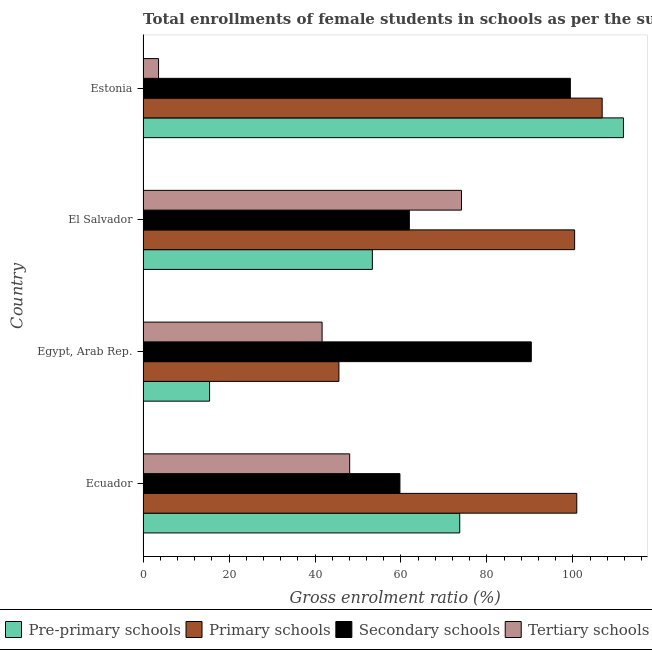How many groups of bars are there?
Give a very brief answer. 4. Are the number of bars per tick equal to the number of legend labels?
Give a very brief answer. Yes. Are the number of bars on each tick of the Y-axis equal?
Offer a terse response. Yes. What is the label of the 4th group of bars from the top?
Provide a succinct answer. Ecuador. In how many cases, is the number of bars for a given country not equal to the number of legend labels?
Keep it short and to the point. 0. What is the gross enrolment ratio(female) in tertiary schools in Ecuador?
Your answer should be very brief. 48.06. Across all countries, what is the maximum gross enrolment ratio(female) in primary schools?
Make the answer very short. 106.8. Across all countries, what is the minimum gross enrolment ratio(female) in tertiary schools?
Your response must be concise. 3.6. In which country was the gross enrolment ratio(female) in primary schools maximum?
Your response must be concise. Estonia. In which country was the gross enrolment ratio(female) in secondary schools minimum?
Provide a short and direct response. Ecuador. What is the total gross enrolment ratio(female) in secondary schools in the graph?
Give a very brief answer. 311.41. What is the difference between the gross enrolment ratio(female) in pre-primary schools in Ecuador and that in Estonia?
Your response must be concise. -38.09. What is the difference between the gross enrolment ratio(female) in primary schools in Ecuador and the gross enrolment ratio(female) in tertiary schools in Egypt, Arab Rep.?
Keep it short and to the point. 59.25. What is the average gross enrolment ratio(female) in secondary schools per country?
Offer a very short reply. 77.85. What is the difference between the gross enrolment ratio(female) in pre-primary schools and gross enrolment ratio(female) in primary schools in El Salvador?
Your answer should be very brief. -47.05. What is the ratio of the gross enrolment ratio(female) in tertiary schools in Ecuador to that in Estonia?
Keep it short and to the point. 13.34. Is the gross enrolment ratio(female) in primary schools in Egypt, Arab Rep. less than that in El Salvador?
Your answer should be compact. Yes. What is the difference between the highest and the second highest gross enrolment ratio(female) in pre-primary schools?
Give a very brief answer. 38.09. What is the difference between the highest and the lowest gross enrolment ratio(female) in pre-primary schools?
Provide a short and direct response. 96.28. Is the sum of the gross enrolment ratio(female) in tertiary schools in El Salvador and Estonia greater than the maximum gross enrolment ratio(female) in secondary schools across all countries?
Your answer should be very brief. No. Is it the case that in every country, the sum of the gross enrolment ratio(female) in tertiary schools and gross enrolment ratio(female) in pre-primary schools is greater than the sum of gross enrolment ratio(female) in secondary schools and gross enrolment ratio(female) in primary schools?
Your response must be concise. No. What does the 3rd bar from the top in El Salvador represents?
Keep it short and to the point. Primary schools. What does the 1st bar from the bottom in El Salvador represents?
Your answer should be very brief. Pre-primary schools. How many bars are there?
Offer a very short reply. 16. How many countries are there in the graph?
Offer a very short reply. 4. What is the difference between two consecutive major ticks on the X-axis?
Your answer should be very brief. 20. Are the values on the major ticks of X-axis written in scientific E-notation?
Your answer should be compact. No. Does the graph contain any zero values?
Provide a succinct answer. No. Does the graph contain grids?
Ensure brevity in your answer.  No. Where does the legend appear in the graph?
Provide a short and direct response. Bottom center. How are the legend labels stacked?
Provide a short and direct response. Horizontal. What is the title of the graph?
Your answer should be compact. Total enrollments of female students in schools as per the survey of 2004 conducted in different countries. Does "International Monetary Fund" appear as one of the legend labels in the graph?
Your answer should be very brief. No. What is the Gross enrolment ratio (%) in Pre-primary schools in Ecuador?
Offer a terse response. 73.67. What is the Gross enrolment ratio (%) of Primary schools in Ecuador?
Make the answer very short. 100.9. What is the Gross enrolment ratio (%) in Secondary schools in Ecuador?
Make the answer very short. 59.76. What is the Gross enrolment ratio (%) of Tertiary schools in Ecuador?
Keep it short and to the point. 48.06. What is the Gross enrolment ratio (%) in Pre-primary schools in Egypt, Arab Rep.?
Give a very brief answer. 15.47. What is the Gross enrolment ratio (%) of Primary schools in Egypt, Arab Rep.?
Offer a very short reply. 45.56. What is the Gross enrolment ratio (%) of Secondary schools in Egypt, Arab Rep.?
Give a very brief answer. 90.31. What is the Gross enrolment ratio (%) in Tertiary schools in Egypt, Arab Rep.?
Offer a very short reply. 41.65. What is the Gross enrolment ratio (%) of Pre-primary schools in El Salvador?
Offer a very short reply. 53.34. What is the Gross enrolment ratio (%) of Primary schools in El Salvador?
Offer a terse response. 100.39. What is the Gross enrolment ratio (%) in Secondary schools in El Salvador?
Your response must be concise. 61.94. What is the Gross enrolment ratio (%) in Tertiary schools in El Salvador?
Give a very brief answer. 74.07. What is the Gross enrolment ratio (%) in Pre-primary schools in Estonia?
Your response must be concise. 111.76. What is the Gross enrolment ratio (%) of Primary schools in Estonia?
Provide a succinct answer. 106.8. What is the Gross enrolment ratio (%) of Secondary schools in Estonia?
Offer a very short reply. 99.4. What is the Gross enrolment ratio (%) in Tertiary schools in Estonia?
Make the answer very short. 3.6. Across all countries, what is the maximum Gross enrolment ratio (%) of Pre-primary schools?
Offer a terse response. 111.76. Across all countries, what is the maximum Gross enrolment ratio (%) of Primary schools?
Provide a succinct answer. 106.8. Across all countries, what is the maximum Gross enrolment ratio (%) of Secondary schools?
Your answer should be compact. 99.4. Across all countries, what is the maximum Gross enrolment ratio (%) of Tertiary schools?
Ensure brevity in your answer.  74.07. Across all countries, what is the minimum Gross enrolment ratio (%) in Pre-primary schools?
Ensure brevity in your answer.  15.47. Across all countries, what is the minimum Gross enrolment ratio (%) of Primary schools?
Your response must be concise. 45.56. Across all countries, what is the minimum Gross enrolment ratio (%) of Secondary schools?
Offer a very short reply. 59.76. Across all countries, what is the minimum Gross enrolment ratio (%) of Tertiary schools?
Ensure brevity in your answer.  3.6. What is the total Gross enrolment ratio (%) in Pre-primary schools in the graph?
Your answer should be compact. 254.24. What is the total Gross enrolment ratio (%) of Primary schools in the graph?
Keep it short and to the point. 353.65. What is the total Gross enrolment ratio (%) of Secondary schools in the graph?
Provide a short and direct response. 311.41. What is the total Gross enrolment ratio (%) in Tertiary schools in the graph?
Your response must be concise. 167.39. What is the difference between the Gross enrolment ratio (%) in Pre-primary schools in Ecuador and that in Egypt, Arab Rep.?
Make the answer very short. 58.19. What is the difference between the Gross enrolment ratio (%) of Primary schools in Ecuador and that in Egypt, Arab Rep.?
Keep it short and to the point. 55.34. What is the difference between the Gross enrolment ratio (%) of Secondary schools in Ecuador and that in Egypt, Arab Rep.?
Provide a short and direct response. -30.56. What is the difference between the Gross enrolment ratio (%) of Tertiary schools in Ecuador and that in Egypt, Arab Rep.?
Your response must be concise. 6.42. What is the difference between the Gross enrolment ratio (%) in Pre-primary schools in Ecuador and that in El Salvador?
Provide a short and direct response. 20.33. What is the difference between the Gross enrolment ratio (%) in Primary schools in Ecuador and that in El Salvador?
Your answer should be very brief. 0.5. What is the difference between the Gross enrolment ratio (%) in Secondary schools in Ecuador and that in El Salvador?
Your answer should be very brief. -2.19. What is the difference between the Gross enrolment ratio (%) in Tertiary schools in Ecuador and that in El Salvador?
Offer a very short reply. -26.01. What is the difference between the Gross enrolment ratio (%) of Pre-primary schools in Ecuador and that in Estonia?
Offer a terse response. -38.09. What is the difference between the Gross enrolment ratio (%) in Primary schools in Ecuador and that in Estonia?
Offer a very short reply. -5.91. What is the difference between the Gross enrolment ratio (%) of Secondary schools in Ecuador and that in Estonia?
Give a very brief answer. -39.64. What is the difference between the Gross enrolment ratio (%) of Tertiary schools in Ecuador and that in Estonia?
Your answer should be compact. 44.46. What is the difference between the Gross enrolment ratio (%) in Pre-primary schools in Egypt, Arab Rep. and that in El Salvador?
Offer a very short reply. -37.87. What is the difference between the Gross enrolment ratio (%) of Primary schools in Egypt, Arab Rep. and that in El Salvador?
Give a very brief answer. -54.83. What is the difference between the Gross enrolment ratio (%) of Secondary schools in Egypt, Arab Rep. and that in El Salvador?
Give a very brief answer. 28.37. What is the difference between the Gross enrolment ratio (%) in Tertiary schools in Egypt, Arab Rep. and that in El Salvador?
Offer a terse response. -32.43. What is the difference between the Gross enrolment ratio (%) of Pre-primary schools in Egypt, Arab Rep. and that in Estonia?
Give a very brief answer. -96.28. What is the difference between the Gross enrolment ratio (%) in Primary schools in Egypt, Arab Rep. and that in Estonia?
Provide a succinct answer. -61.24. What is the difference between the Gross enrolment ratio (%) of Secondary schools in Egypt, Arab Rep. and that in Estonia?
Offer a terse response. -9.08. What is the difference between the Gross enrolment ratio (%) in Tertiary schools in Egypt, Arab Rep. and that in Estonia?
Provide a short and direct response. 38.04. What is the difference between the Gross enrolment ratio (%) in Pre-primary schools in El Salvador and that in Estonia?
Provide a short and direct response. -58.41. What is the difference between the Gross enrolment ratio (%) of Primary schools in El Salvador and that in Estonia?
Your answer should be very brief. -6.41. What is the difference between the Gross enrolment ratio (%) in Secondary schools in El Salvador and that in Estonia?
Offer a very short reply. -37.45. What is the difference between the Gross enrolment ratio (%) in Tertiary schools in El Salvador and that in Estonia?
Give a very brief answer. 70.47. What is the difference between the Gross enrolment ratio (%) in Pre-primary schools in Ecuador and the Gross enrolment ratio (%) in Primary schools in Egypt, Arab Rep.?
Your answer should be compact. 28.11. What is the difference between the Gross enrolment ratio (%) of Pre-primary schools in Ecuador and the Gross enrolment ratio (%) of Secondary schools in Egypt, Arab Rep.?
Keep it short and to the point. -16.65. What is the difference between the Gross enrolment ratio (%) of Pre-primary schools in Ecuador and the Gross enrolment ratio (%) of Tertiary schools in Egypt, Arab Rep.?
Your answer should be compact. 32.02. What is the difference between the Gross enrolment ratio (%) in Primary schools in Ecuador and the Gross enrolment ratio (%) in Secondary schools in Egypt, Arab Rep.?
Your answer should be very brief. 10.58. What is the difference between the Gross enrolment ratio (%) in Primary schools in Ecuador and the Gross enrolment ratio (%) in Tertiary schools in Egypt, Arab Rep.?
Your response must be concise. 59.25. What is the difference between the Gross enrolment ratio (%) of Secondary schools in Ecuador and the Gross enrolment ratio (%) of Tertiary schools in Egypt, Arab Rep.?
Make the answer very short. 18.11. What is the difference between the Gross enrolment ratio (%) in Pre-primary schools in Ecuador and the Gross enrolment ratio (%) in Primary schools in El Salvador?
Your response must be concise. -26.73. What is the difference between the Gross enrolment ratio (%) of Pre-primary schools in Ecuador and the Gross enrolment ratio (%) of Secondary schools in El Salvador?
Provide a short and direct response. 11.72. What is the difference between the Gross enrolment ratio (%) in Pre-primary schools in Ecuador and the Gross enrolment ratio (%) in Tertiary schools in El Salvador?
Provide a succinct answer. -0.41. What is the difference between the Gross enrolment ratio (%) of Primary schools in Ecuador and the Gross enrolment ratio (%) of Secondary schools in El Salvador?
Give a very brief answer. 38.95. What is the difference between the Gross enrolment ratio (%) of Primary schools in Ecuador and the Gross enrolment ratio (%) of Tertiary schools in El Salvador?
Your answer should be compact. 26.82. What is the difference between the Gross enrolment ratio (%) of Secondary schools in Ecuador and the Gross enrolment ratio (%) of Tertiary schools in El Salvador?
Your answer should be compact. -14.32. What is the difference between the Gross enrolment ratio (%) in Pre-primary schools in Ecuador and the Gross enrolment ratio (%) in Primary schools in Estonia?
Ensure brevity in your answer.  -33.13. What is the difference between the Gross enrolment ratio (%) of Pre-primary schools in Ecuador and the Gross enrolment ratio (%) of Secondary schools in Estonia?
Provide a succinct answer. -25.73. What is the difference between the Gross enrolment ratio (%) of Pre-primary schools in Ecuador and the Gross enrolment ratio (%) of Tertiary schools in Estonia?
Make the answer very short. 70.06. What is the difference between the Gross enrolment ratio (%) in Primary schools in Ecuador and the Gross enrolment ratio (%) in Secondary schools in Estonia?
Make the answer very short. 1.5. What is the difference between the Gross enrolment ratio (%) of Primary schools in Ecuador and the Gross enrolment ratio (%) of Tertiary schools in Estonia?
Your answer should be compact. 97.29. What is the difference between the Gross enrolment ratio (%) in Secondary schools in Ecuador and the Gross enrolment ratio (%) in Tertiary schools in Estonia?
Your answer should be compact. 56.15. What is the difference between the Gross enrolment ratio (%) of Pre-primary schools in Egypt, Arab Rep. and the Gross enrolment ratio (%) of Primary schools in El Salvador?
Offer a terse response. -84.92. What is the difference between the Gross enrolment ratio (%) in Pre-primary schools in Egypt, Arab Rep. and the Gross enrolment ratio (%) in Secondary schools in El Salvador?
Make the answer very short. -46.47. What is the difference between the Gross enrolment ratio (%) in Pre-primary schools in Egypt, Arab Rep. and the Gross enrolment ratio (%) in Tertiary schools in El Salvador?
Ensure brevity in your answer.  -58.6. What is the difference between the Gross enrolment ratio (%) in Primary schools in Egypt, Arab Rep. and the Gross enrolment ratio (%) in Secondary schools in El Salvador?
Keep it short and to the point. -16.38. What is the difference between the Gross enrolment ratio (%) in Primary schools in Egypt, Arab Rep. and the Gross enrolment ratio (%) in Tertiary schools in El Salvador?
Your response must be concise. -28.51. What is the difference between the Gross enrolment ratio (%) of Secondary schools in Egypt, Arab Rep. and the Gross enrolment ratio (%) of Tertiary schools in El Salvador?
Provide a short and direct response. 16.24. What is the difference between the Gross enrolment ratio (%) of Pre-primary schools in Egypt, Arab Rep. and the Gross enrolment ratio (%) of Primary schools in Estonia?
Your response must be concise. -91.33. What is the difference between the Gross enrolment ratio (%) of Pre-primary schools in Egypt, Arab Rep. and the Gross enrolment ratio (%) of Secondary schools in Estonia?
Your answer should be very brief. -83.92. What is the difference between the Gross enrolment ratio (%) of Pre-primary schools in Egypt, Arab Rep. and the Gross enrolment ratio (%) of Tertiary schools in Estonia?
Your response must be concise. 11.87. What is the difference between the Gross enrolment ratio (%) in Primary schools in Egypt, Arab Rep. and the Gross enrolment ratio (%) in Secondary schools in Estonia?
Ensure brevity in your answer.  -53.84. What is the difference between the Gross enrolment ratio (%) in Primary schools in Egypt, Arab Rep. and the Gross enrolment ratio (%) in Tertiary schools in Estonia?
Your response must be concise. 41.96. What is the difference between the Gross enrolment ratio (%) in Secondary schools in Egypt, Arab Rep. and the Gross enrolment ratio (%) in Tertiary schools in Estonia?
Make the answer very short. 86.71. What is the difference between the Gross enrolment ratio (%) in Pre-primary schools in El Salvador and the Gross enrolment ratio (%) in Primary schools in Estonia?
Your answer should be compact. -53.46. What is the difference between the Gross enrolment ratio (%) in Pre-primary schools in El Salvador and the Gross enrolment ratio (%) in Secondary schools in Estonia?
Make the answer very short. -46.06. What is the difference between the Gross enrolment ratio (%) of Pre-primary schools in El Salvador and the Gross enrolment ratio (%) of Tertiary schools in Estonia?
Offer a very short reply. 49.74. What is the difference between the Gross enrolment ratio (%) in Primary schools in El Salvador and the Gross enrolment ratio (%) in Tertiary schools in Estonia?
Keep it short and to the point. 96.79. What is the difference between the Gross enrolment ratio (%) of Secondary schools in El Salvador and the Gross enrolment ratio (%) of Tertiary schools in Estonia?
Provide a succinct answer. 58.34. What is the average Gross enrolment ratio (%) of Pre-primary schools per country?
Provide a succinct answer. 63.56. What is the average Gross enrolment ratio (%) in Primary schools per country?
Ensure brevity in your answer.  88.41. What is the average Gross enrolment ratio (%) of Secondary schools per country?
Keep it short and to the point. 77.85. What is the average Gross enrolment ratio (%) of Tertiary schools per country?
Offer a terse response. 41.85. What is the difference between the Gross enrolment ratio (%) in Pre-primary schools and Gross enrolment ratio (%) in Primary schools in Ecuador?
Make the answer very short. -27.23. What is the difference between the Gross enrolment ratio (%) in Pre-primary schools and Gross enrolment ratio (%) in Secondary schools in Ecuador?
Make the answer very short. 13.91. What is the difference between the Gross enrolment ratio (%) of Pre-primary schools and Gross enrolment ratio (%) of Tertiary schools in Ecuador?
Provide a short and direct response. 25.6. What is the difference between the Gross enrolment ratio (%) in Primary schools and Gross enrolment ratio (%) in Secondary schools in Ecuador?
Your answer should be very brief. 41.14. What is the difference between the Gross enrolment ratio (%) of Primary schools and Gross enrolment ratio (%) of Tertiary schools in Ecuador?
Your answer should be very brief. 52.83. What is the difference between the Gross enrolment ratio (%) in Secondary schools and Gross enrolment ratio (%) in Tertiary schools in Ecuador?
Offer a very short reply. 11.69. What is the difference between the Gross enrolment ratio (%) of Pre-primary schools and Gross enrolment ratio (%) of Primary schools in Egypt, Arab Rep.?
Provide a short and direct response. -30.09. What is the difference between the Gross enrolment ratio (%) in Pre-primary schools and Gross enrolment ratio (%) in Secondary schools in Egypt, Arab Rep.?
Provide a succinct answer. -74.84. What is the difference between the Gross enrolment ratio (%) in Pre-primary schools and Gross enrolment ratio (%) in Tertiary schools in Egypt, Arab Rep.?
Make the answer very short. -26.17. What is the difference between the Gross enrolment ratio (%) of Primary schools and Gross enrolment ratio (%) of Secondary schools in Egypt, Arab Rep.?
Ensure brevity in your answer.  -44.75. What is the difference between the Gross enrolment ratio (%) of Primary schools and Gross enrolment ratio (%) of Tertiary schools in Egypt, Arab Rep.?
Offer a very short reply. 3.91. What is the difference between the Gross enrolment ratio (%) in Secondary schools and Gross enrolment ratio (%) in Tertiary schools in Egypt, Arab Rep.?
Your answer should be compact. 48.67. What is the difference between the Gross enrolment ratio (%) of Pre-primary schools and Gross enrolment ratio (%) of Primary schools in El Salvador?
Give a very brief answer. -47.05. What is the difference between the Gross enrolment ratio (%) in Pre-primary schools and Gross enrolment ratio (%) in Secondary schools in El Salvador?
Ensure brevity in your answer.  -8.6. What is the difference between the Gross enrolment ratio (%) in Pre-primary schools and Gross enrolment ratio (%) in Tertiary schools in El Salvador?
Your answer should be very brief. -20.73. What is the difference between the Gross enrolment ratio (%) in Primary schools and Gross enrolment ratio (%) in Secondary schools in El Salvador?
Make the answer very short. 38.45. What is the difference between the Gross enrolment ratio (%) of Primary schools and Gross enrolment ratio (%) of Tertiary schools in El Salvador?
Ensure brevity in your answer.  26.32. What is the difference between the Gross enrolment ratio (%) in Secondary schools and Gross enrolment ratio (%) in Tertiary schools in El Salvador?
Provide a short and direct response. -12.13. What is the difference between the Gross enrolment ratio (%) of Pre-primary schools and Gross enrolment ratio (%) of Primary schools in Estonia?
Give a very brief answer. 4.95. What is the difference between the Gross enrolment ratio (%) of Pre-primary schools and Gross enrolment ratio (%) of Secondary schools in Estonia?
Provide a succinct answer. 12.36. What is the difference between the Gross enrolment ratio (%) of Pre-primary schools and Gross enrolment ratio (%) of Tertiary schools in Estonia?
Offer a terse response. 108.15. What is the difference between the Gross enrolment ratio (%) of Primary schools and Gross enrolment ratio (%) of Secondary schools in Estonia?
Keep it short and to the point. 7.4. What is the difference between the Gross enrolment ratio (%) of Primary schools and Gross enrolment ratio (%) of Tertiary schools in Estonia?
Provide a succinct answer. 103.2. What is the difference between the Gross enrolment ratio (%) in Secondary schools and Gross enrolment ratio (%) in Tertiary schools in Estonia?
Your answer should be compact. 95.8. What is the ratio of the Gross enrolment ratio (%) in Pre-primary schools in Ecuador to that in Egypt, Arab Rep.?
Ensure brevity in your answer.  4.76. What is the ratio of the Gross enrolment ratio (%) in Primary schools in Ecuador to that in Egypt, Arab Rep.?
Your answer should be very brief. 2.21. What is the ratio of the Gross enrolment ratio (%) of Secondary schools in Ecuador to that in Egypt, Arab Rep.?
Provide a succinct answer. 0.66. What is the ratio of the Gross enrolment ratio (%) in Tertiary schools in Ecuador to that in Egypt, Arab Rep.?
Your answer should be very brief. 1.15. What is the ratio of the Gross enrolment ratio (%) in Pre-primary schools in Ecuador to that in El Salvador?
Keep it short and to the point. 1.38. What is the ratio of the Gross enrolment ratio (%) in Primary schools in Ecuador to that in El Salvador?
Offer a terse response. 1. What is the ratio of the Gross enrolment ratio (%) of Secondary schools in Ecuador to that in El Salvador?
Your answer should be compact. 0.96. What is the ratio of the Gross enrolment ratio (%) of Tertiary schools in Ecuador to that in El Salvador?
Offer a terse response. 0.65. What is the ratio of the Gross enrolment ratio (%) of Pre-primary schools in Ecuador to that in Estonia?
Ensure brevity in your answer.  0.66. What is the ratio of the Gross enrolment ratio (%) of Primary schools in Ecuador to that in Estonia?
Ensure brevity in your answer.  0.94. What is the ratio of the Gross enrolment ratio (%) in Secondary schools in Ecuador to that in Estonia?
Offer a terse response. 0.6. What is the ratio of the Gross enrolment ratio (%) in Tertiary schools in Ecuador to that in Estonia?
Provide a succinct answer. 13.34. What is the ratio of the Gross enrolment ratio (%) of Pre-primary schools in Egypt, Arab Rep. to that in El Salvador?
Ensure brevity in your answer.  0.29. What is the ratio of the Gross enrolment ratio (%) of Primary schools in Egypt, Arab Rep. to that in El Salvador?
Your answer should be compact. 0.45. What is the ratio of the Gross enrolment ratio (%) of Secondary schools in Egypt, Arab Rep. to that in El Salvador?
Make the answer very short. 1.46. What is the ratio of the Gross enrolment ratio (%) in Tertiary schools in Egypt, Arab Rep. to that in El Salvador?
Your answer should be very brief. 0.56. What is the ratio of the Gross enrolment ratio (%) in Pre-primary schools in Egypt, Arab Rep. to that in Estonia?
Your response must be concise. 0.14. What is the ratio of the Gross enrolment ratio (%) of Primary schools in Egypt, Arab Rep. to that in Estonia?
Offer a very short reply. 0.43. What is the ratio of the Gross enrolment ratio (%) of Secondary schools in Egypt, Arab Rep. to that in Estonia?
Your answer should be very brief. 0.91. What is the ratio of the Gross enrolment ratio (%) in Tertiary schools in Egypt, Arab Rep. to that in Estonia?
Offer a very short reply. 11.56. What is the ratio of the Gross enrolment ratio (%) of Pre-primary schools in El Salvador to that in Estonia?
Make the answer very short. 0.48. What is the ratio of the Gross enrolment ratio (%) in Secondary schools in El Salvador to that in Estonia?
Provide a succinct answer. 0.62. What is the ratio of the Gross enrolment ratio (%) in Tertiary schools in El Salvador to that in Estonia?
Your answer should be very brief. 20.56. What is the difference between the highest and the second highest Gross enrolment ratio (%) of Pre-primary schools?
Make the answer very short. 38.09. What is the difference between the highest and the second highest Gross enrolment ratio (%) of Primary schools?
Your response must be concise. 5.91. What is the difference between the highest and the second highest Gross enrolment ratio (%) in Secondary schools?
Offer a terse response. 9.08. What is the difference between the highest and the second highest Gross enrolment ratio (%) of Tertiary schools?
Offer a terse response. 26.01. What is the difference between the highest and the lowest Gross enrolment ratio (%) in Pre-primary schools?
Offer a terse response. 96.28. What is the difference between the highest and the lowest Gross enrolment ratio (%) in Primary schools?
Provide a short and direct response. 61.24. What is the difference between the highest and the lowest Gross enrolment ratio (%) of Secondary schools?
Your answer should be very brief. 39.64. What is the difference between the highest and the lowest Gross enrolment ratio (%) of Tertiary schools?
Your response must be concise. 70.47. 